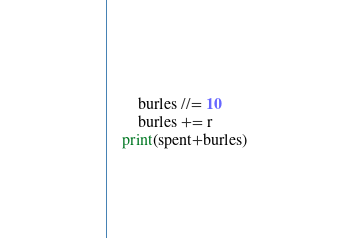<code> <loc_0><loc_0><loc_500><loc_500><_Python_>        burles //= 10
        burles += r
    print(spent+burles)</code> 